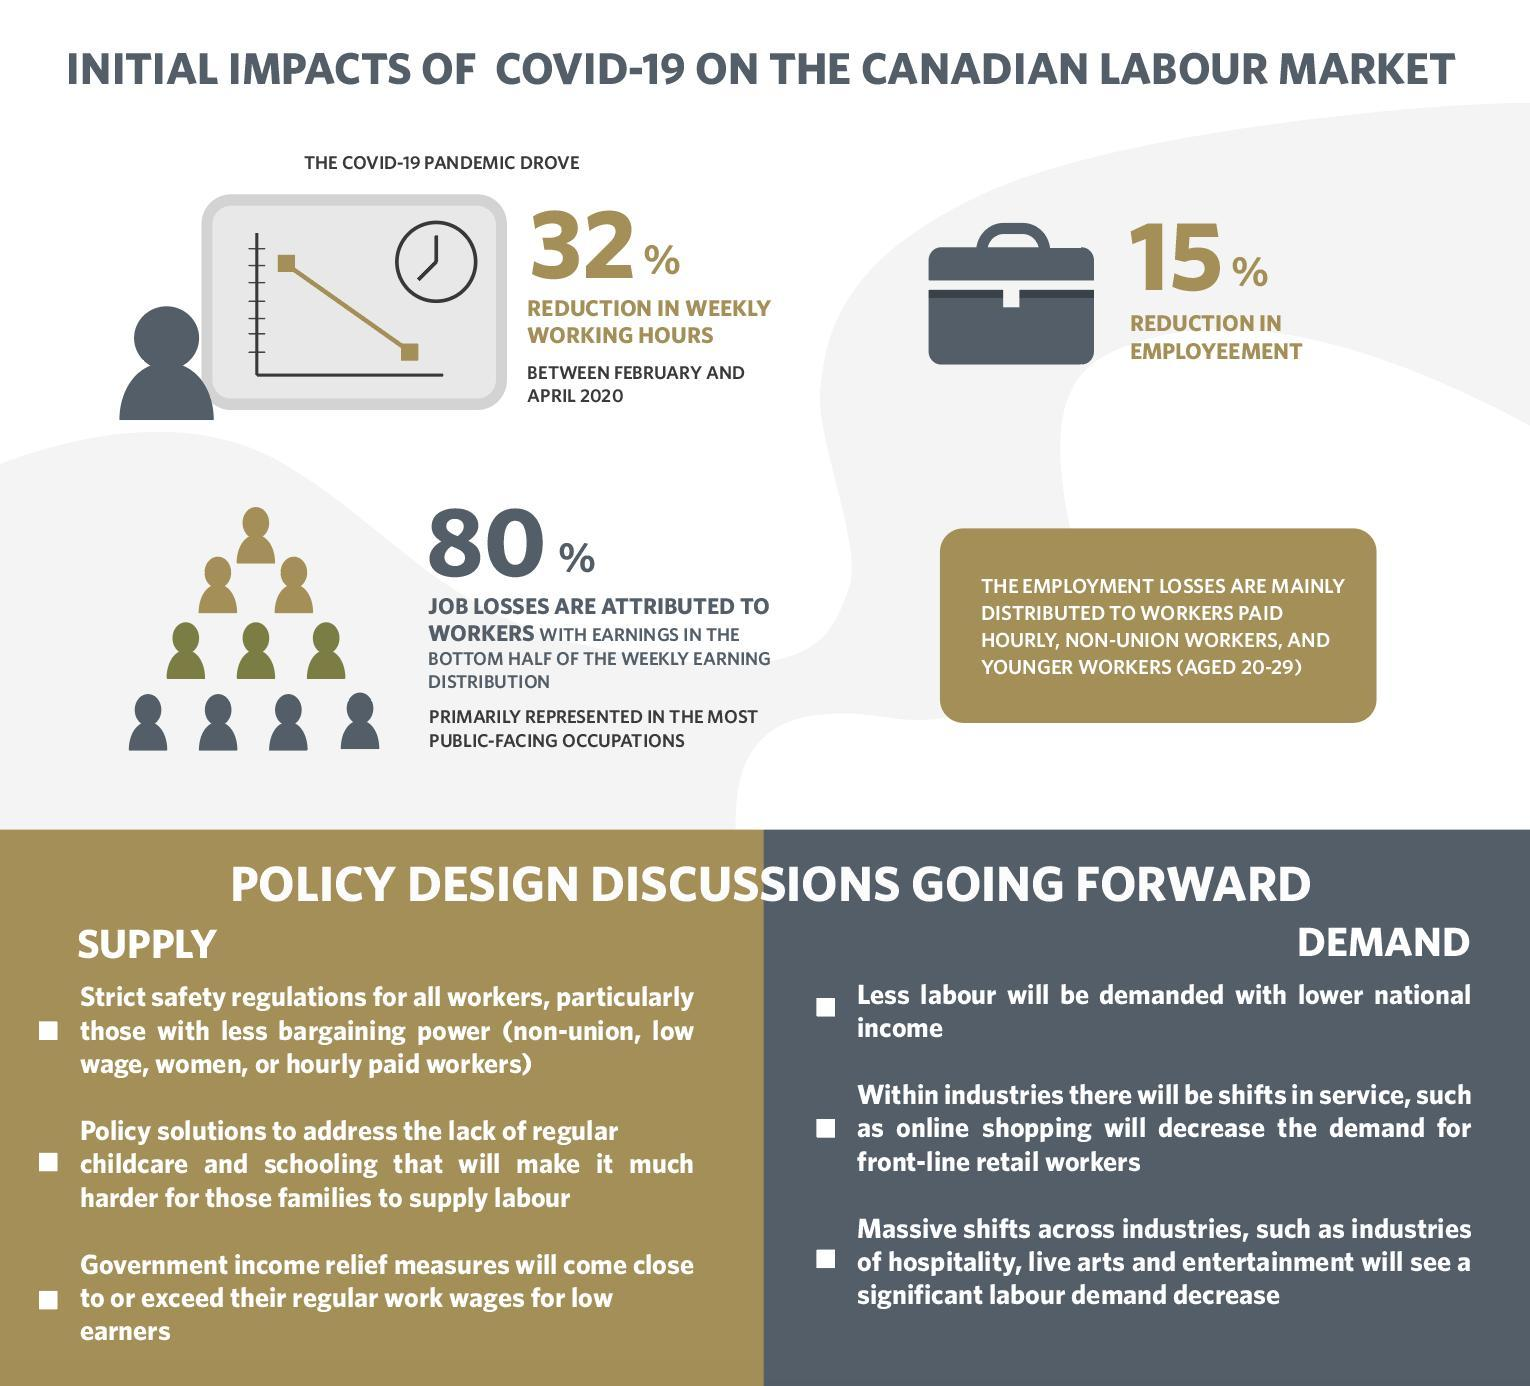What is the percentage reduction in the employment due to the impact of COVID-19 on the Canadian labour market?
Answer the question with a short phrase. 15% 